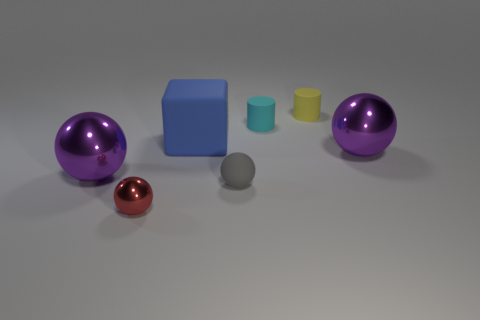How does the lighting affect the appearance of the objects? The lighting in the image looks soft and diffused, which creates gentle shadows and subtle highlights on the objects. This type of lighting reduces the harshness of shadows and allows the colors and textures to be seen more clearly. The metallic spheres reflect the light strongly, emphasizing their glossy finish, whereas the rubber or plastic objects absorb more light, showcasing their colors without distracting glares. The soft lighting also reveals the texture of the tiny gray object, which might be lost with harsher lighting. 